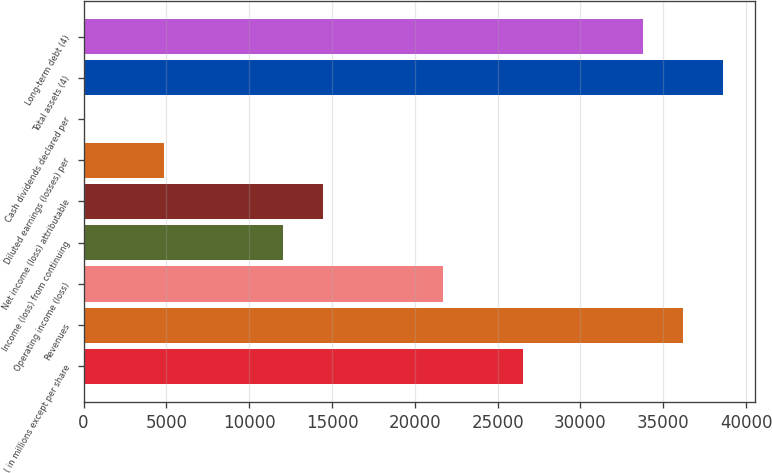<chart> <loc_0><loc_0><loc_500><loc_500><bar_chart><fcel>( in millions except per share<fcel>Revenues<fcel>Operating income (loss)<fcel>Income (loss) from continuing<fcel>Net income (loss) attributable<fcel>Diluted earnings (losses) per<fcel>Cash dividends declared per<fcel>Total assets (4)<fcel>Long-term debt (4)<nl><fcel>26553.9<fcel>36209.4<fcel>21726.1<fcel>12070.6<fcel>14484.5<fcel>4828.91<fcel>1.15<fcel>38623.3<fcel>33795.5<nl></chart> 